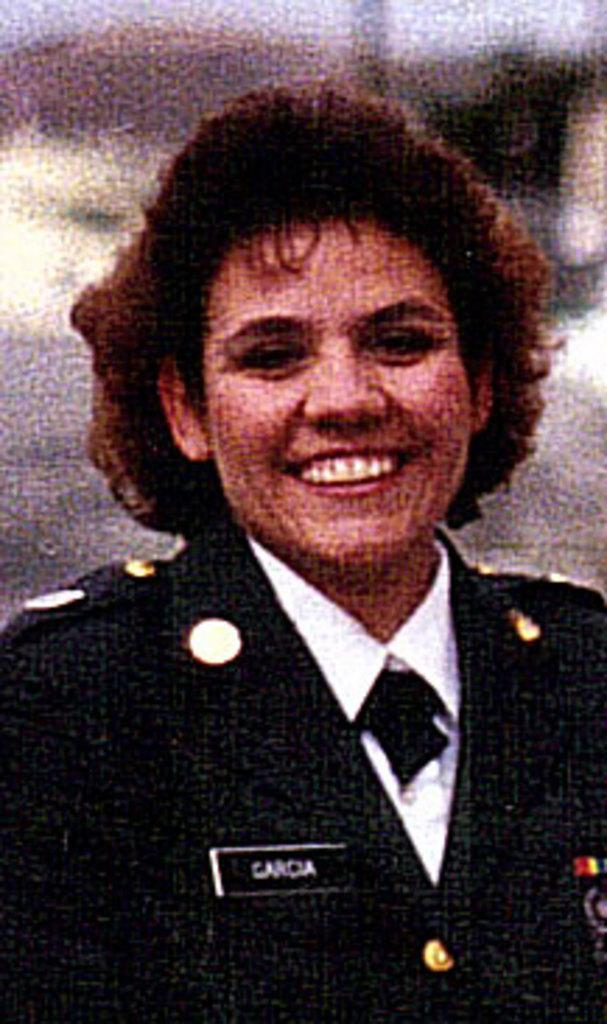What is the main subject of the image? The main subject of the image is a woman. What is the woman doing in the image? The woman is standing in the image. What is the woman wearing in the image? The woman is wearing a black dress in the image. What type of kettle can be seen in the background of the image? There is no kettle present in the image; it only features a woman standing in a black dress. What songs is the woman singing in the image? The image does not show the woman singing any songs. 